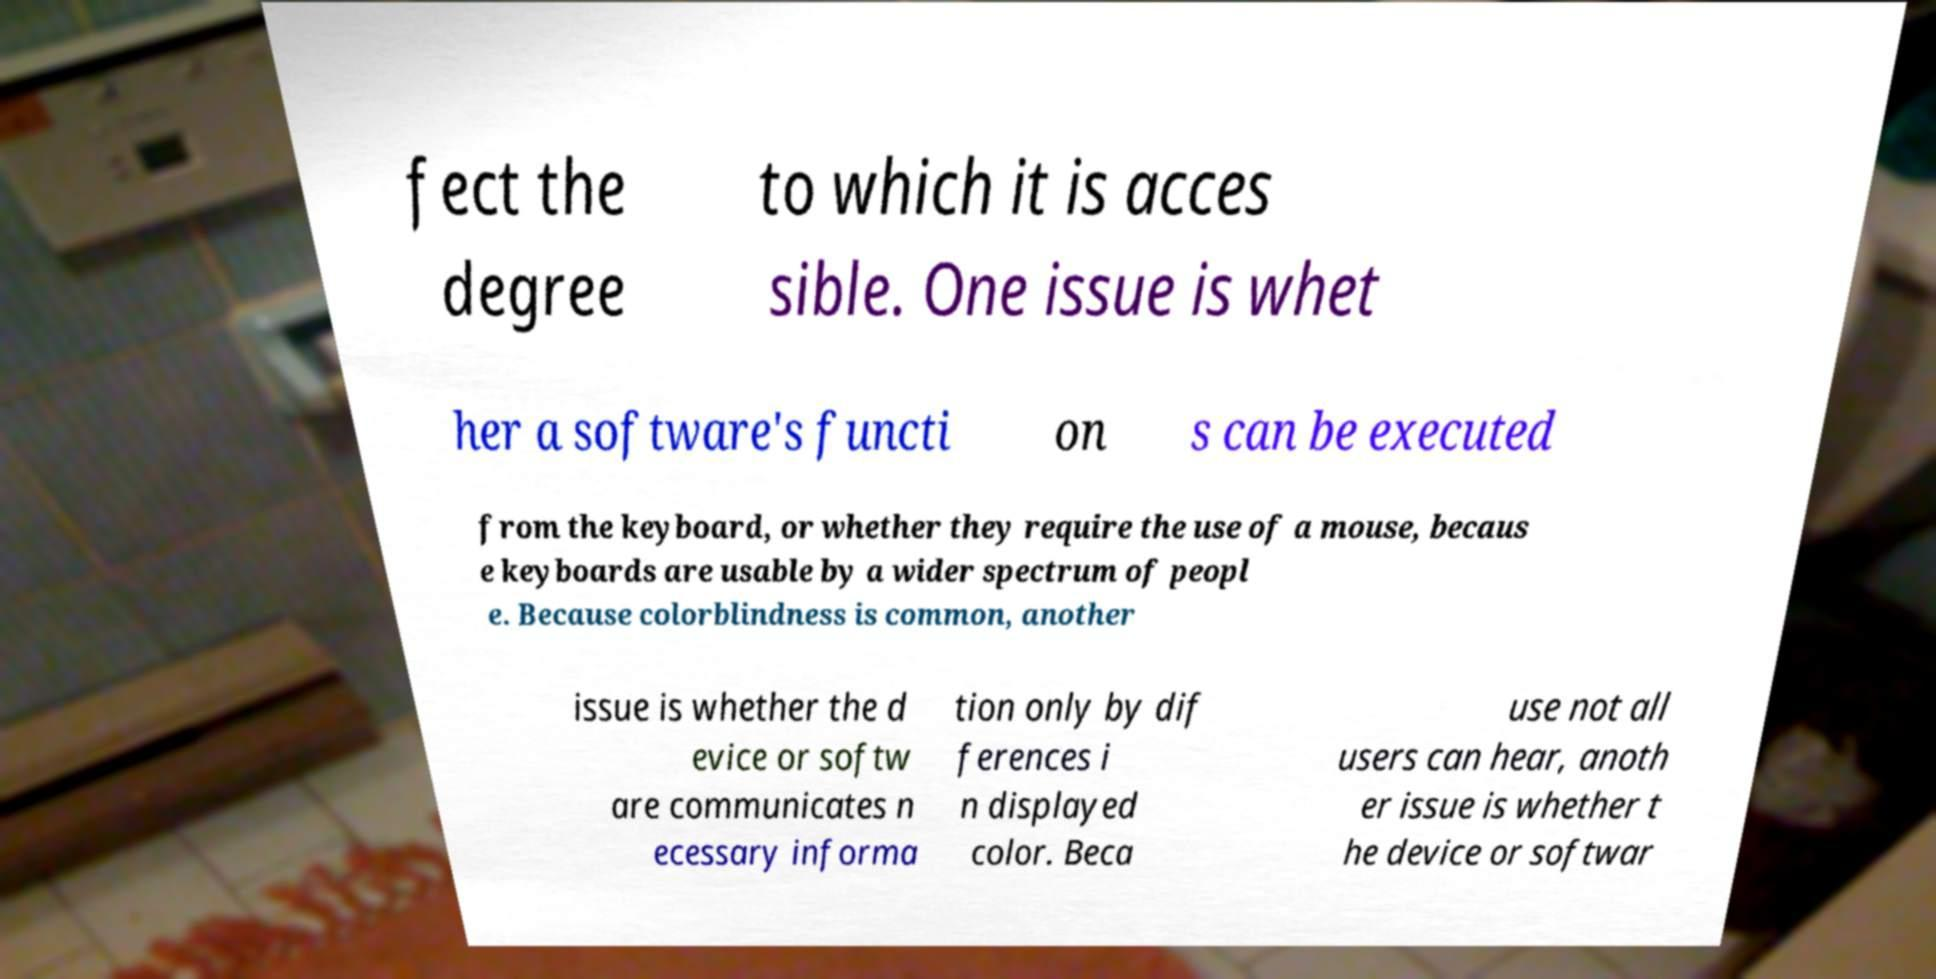Could you extract and type out the text from this image? fect the degree to which it is acces sible. One issue is whet her a software's functi on s can be executed from the keyboard, or whether they require the use of a mouse, becaus e keyboards are usable by a wider spectrum of peopl e. Because colorblindness is common, another issue is whether the d evice or softw are communicates n ecessary informa tion only by dif ferences i n displayed color. Beca use not all users can hear, anoth er issue is whether t he device or softwar 